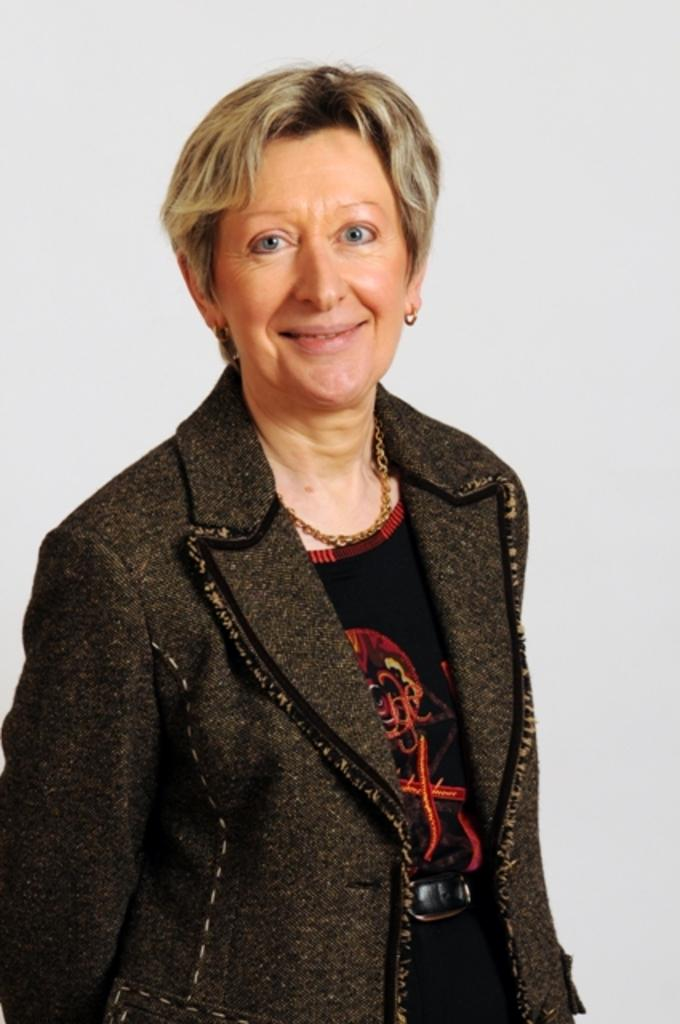Who is present in the image? There is a woman in the image. What is the woman wearing? The woman is wearing a sweater. What is the color of the background in the image? The background of the image is white. How many bikes are parked in the lunchroom in the image? There are no bikes or lunchroom present in the image; it features a woman wearing a sweater against a white background. 